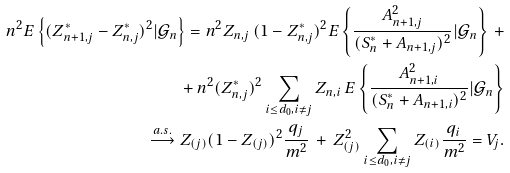Convert formula to latex. <formula><loc_0><loc_0><loc_500><loc_500>n ^ { 2 } E \left \{ ( Z _ { n + 1 , j } ^ { * } - Z _ { n , j } ^ { * } ) ^ { 2 } | \mathcal { G } _ { n } \right \} = n ^ { 2 } Z _ { n , j } \, ( 1 - Z _ { n , j } ^ { * } ) ^ { 2 } E \left \{ \frac { A _ { n + 1 , j } ^ { 2 } } { ( S _ { n } ^ { * } + A _ { n + 1 , j } ) ^ { 2 } } | \mathcal { G } _ { n } \right \} \, + \\ + \, n ^ { 2 } ( Z _ { n , j } ^ { * } ) ^ { 2 } \sum _ { i \leq d _ { 0 } , i \neq j } Z _ { n , i } \, E \left \{ \frac { A _ { n + 1 , i } ^ { 2 } } { ( S _ { n } ^ { * } + A _ { n + 1 , i } ) ^ { 2 } } | \mathcal { G } _ { n } \right \} \\ \overset { a . s . } \longrightarrow Z _ { ( j ) } ( 1 - Z _ { ( j ) } ) ^ { 2 } \frac { q _ { j } } { m ^ { 2 } } \, + \, Z _ { ( j ) } ^ { 2 } \sum _ { i \leq d _ { 0 } , i \neq j } Z _ { ( i ) } \frac { q _ { i } } { m ^ { 2 } } = V _ { j } .</formula> 